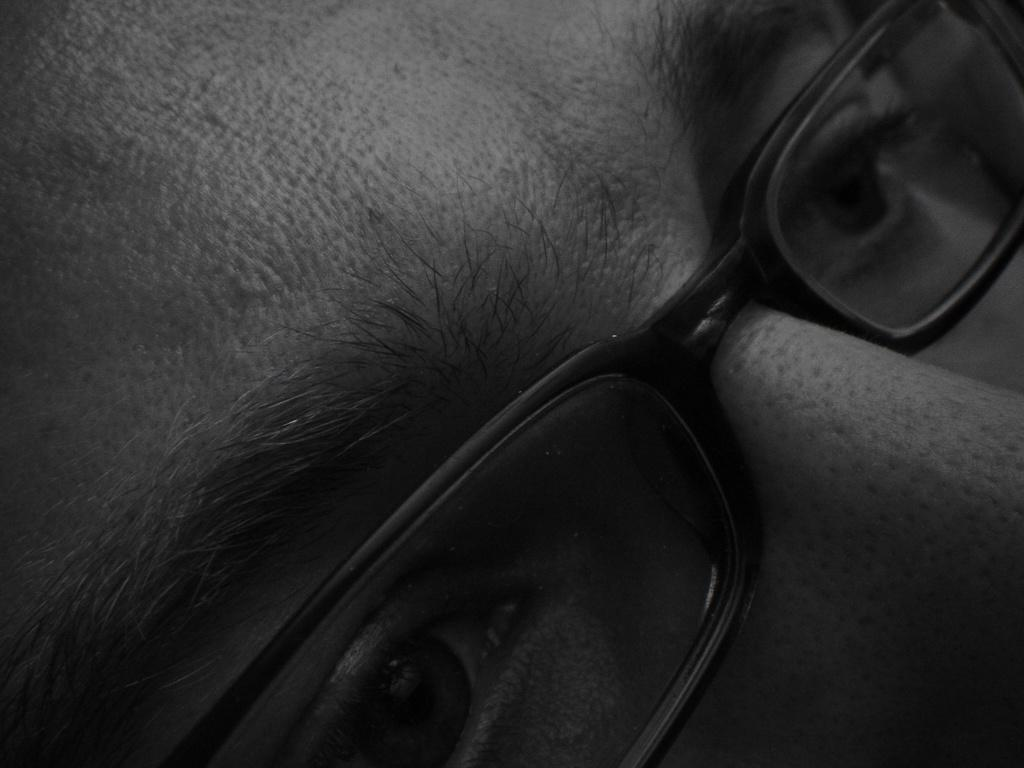What is the color scheme of the image? The image is black and white. What can be seen in the image? There is a person's face in the image. What accessory is the person wearing in the image? The person is wearing spectacles. Where is the stamp located in the image? There is no stamp present in the image. What type of oven is visible in the image? There is no oven present in the image. 